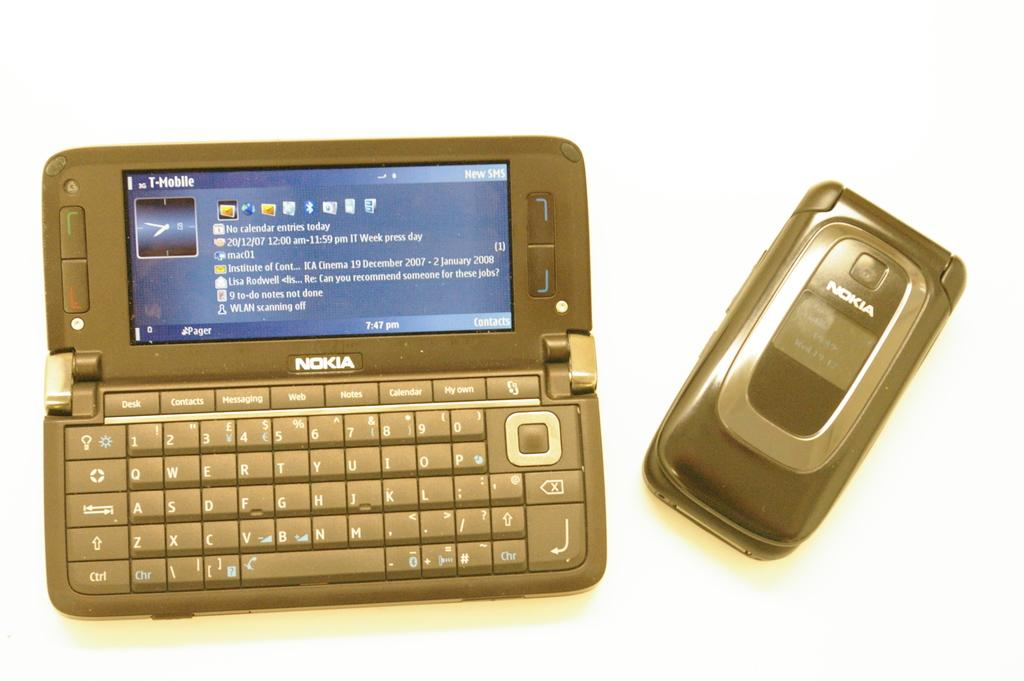Provide a one-sentence caption for the provided image. a Nokia flip phone with the carrier T Mobile. 